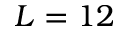Convert formula to latex. <formula><loc_0><loc_0><loc_500><loc_500>L = 1 2</formula> 